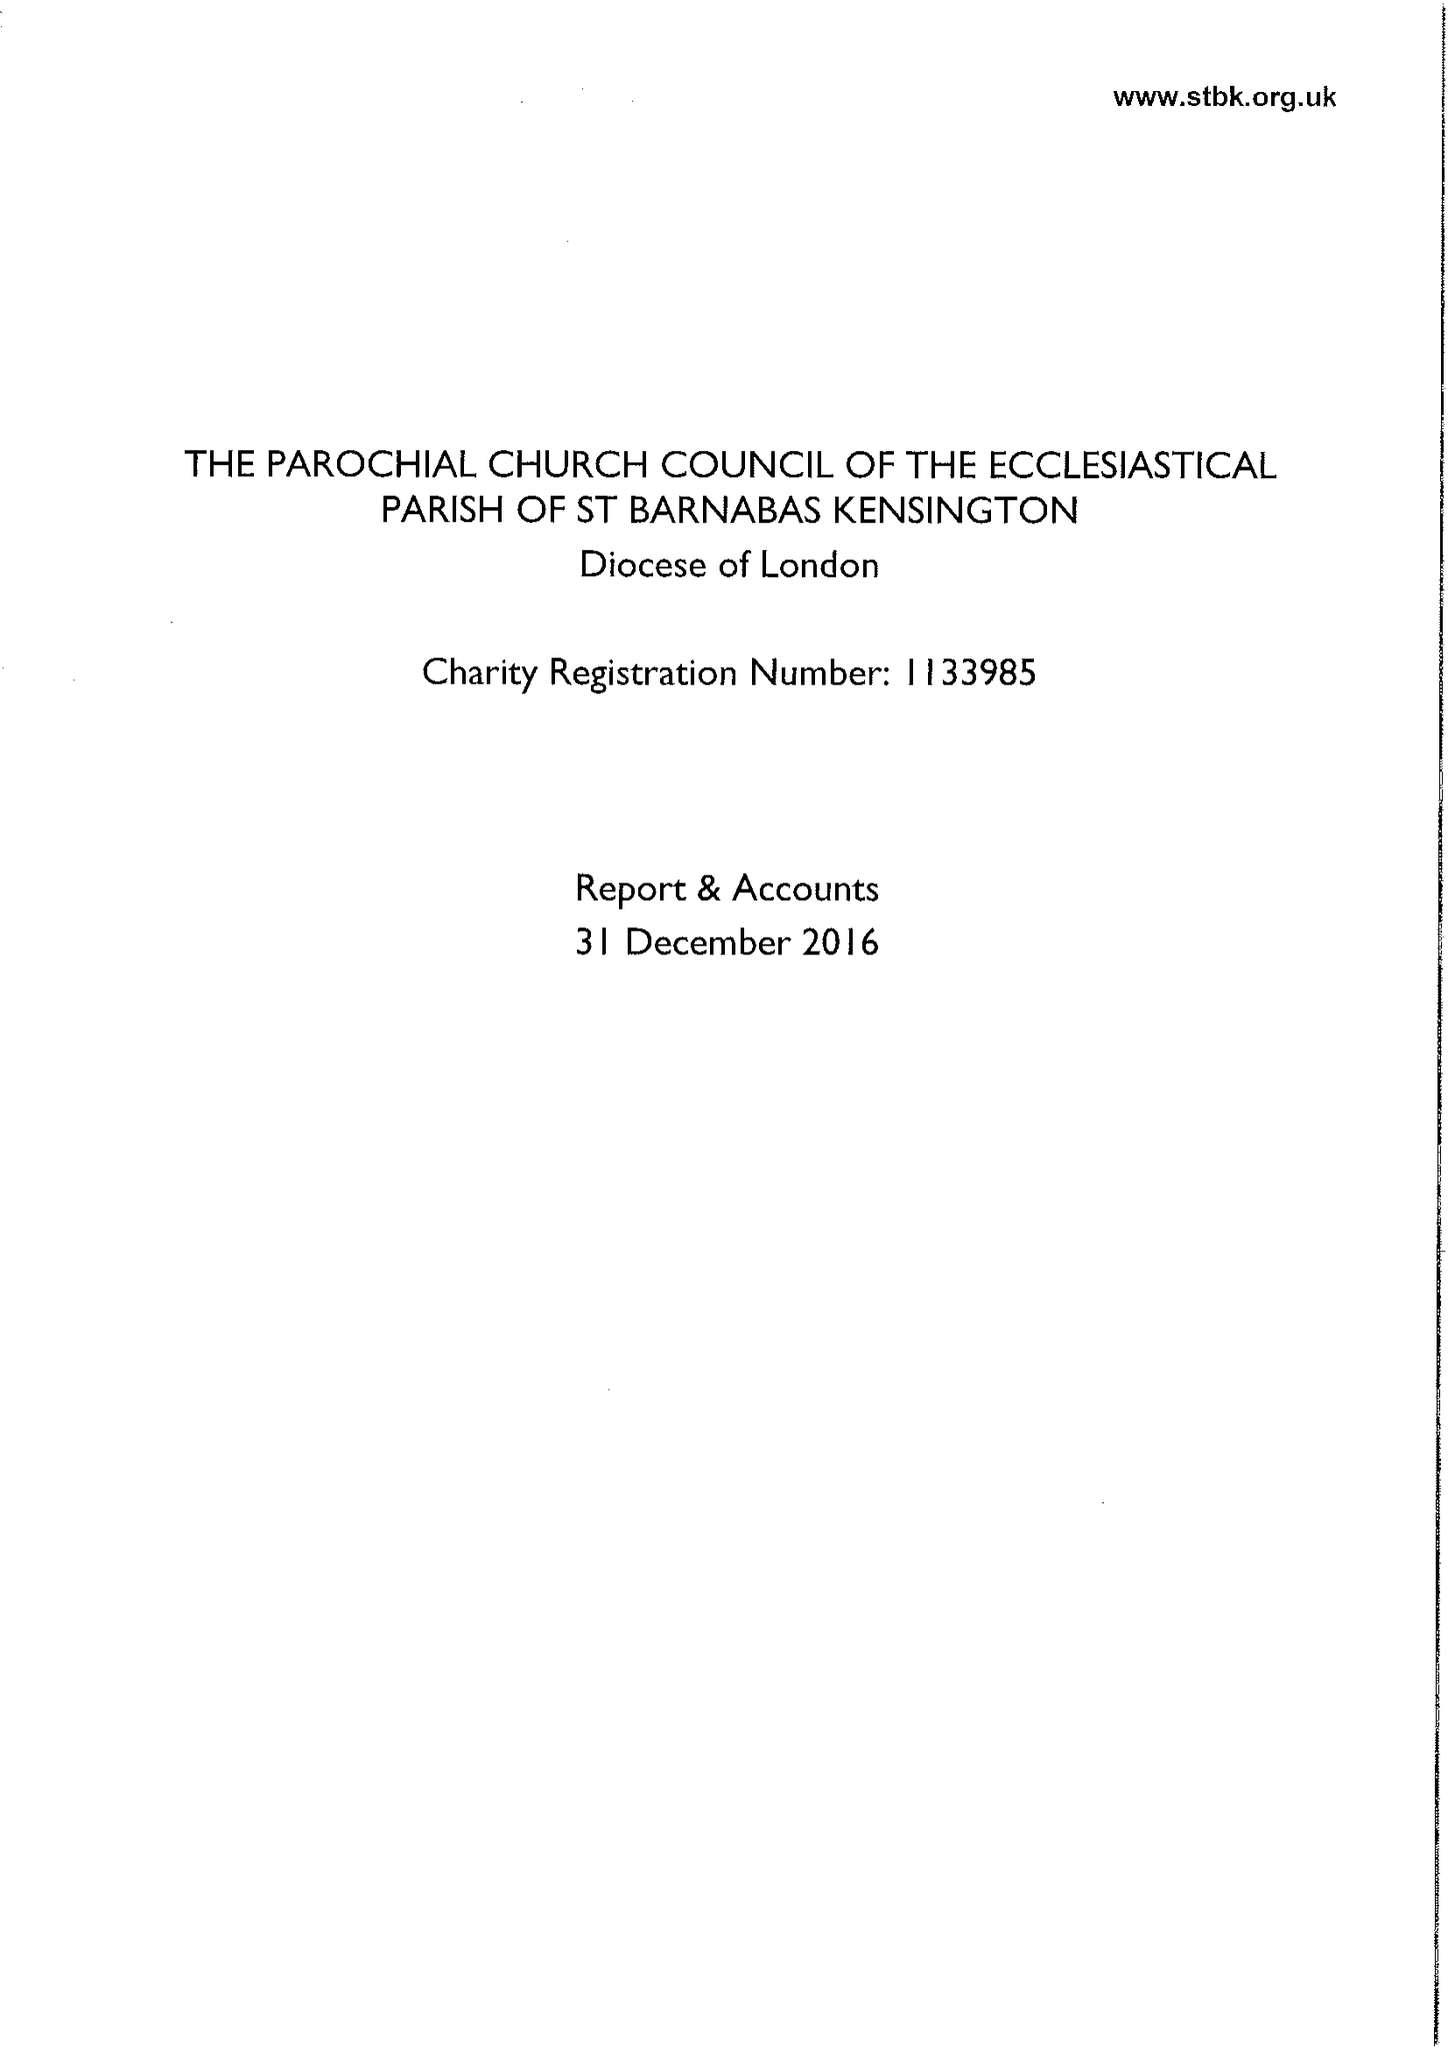What is the value for the income_annually_in_british_pounds?
Answer the question using a single word or phrase. 472838.00 